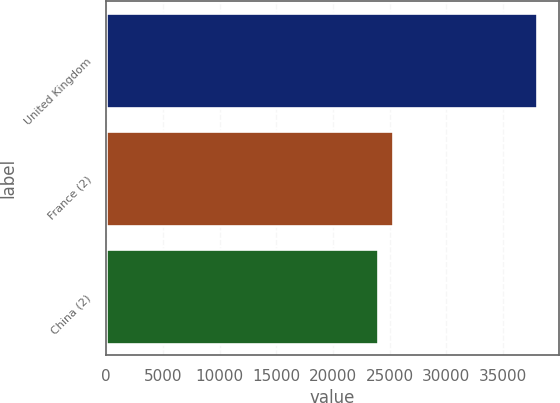<chart> <loc_0><loc_0><loc_500><loc_500><bar_chart><fcel>United Kingdom<fcel>France (2)<fcel>China (2)<nl><fcel>37999<fcel>25335.1<fcel>23928<nl></chart> 